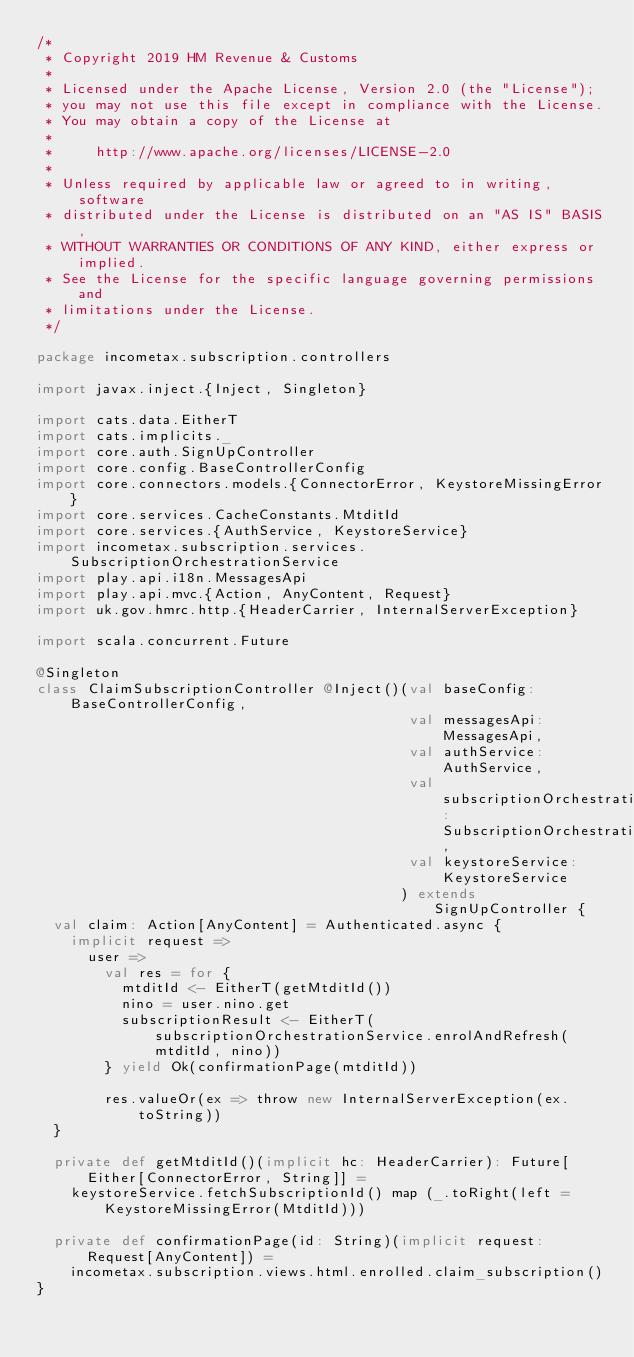<code> <loc_0><loc_0><loc_500><loc_500><_Scala_>/*
 * Copyright 2019 HM Revenue & Customs
 *
 * Licensed under the Apache License, Version 2.0 (the "License");
 * you may not use this file except in compliance with the License.
 * You may obtain a copy of the License at
 *
 *     http://www.apache.org/licenses/LICENSE-2.0
 *
 * Unless required by applicable law or agreed to in writing, software
 * distributed under the License is distributed on an "AS IS" BASIS,
 * WITHOUT WARRANTIES OR CONDITIONS OF ANY KIND, either express or implied.
 * See the License for the specific language governing permissions and
 * limitations under the License.
 */

package incometax.subscription.controllers

import javax.inject.{Inject, Singleton}

import cats.data.EitherT
import cats.implicits._
import core.auth.SignUpController
import core.config.BaseControllerConfig
import core.connectors.models.{ConnectorError, KeystoreMissingError}
import core.services.CacheConstants.MtditId
import core.services.{AuthService, KeystoreService}
import incometax.subscription.services.SubscriptionOrchestrationService
import play.api.i18n.MessagesApi
import play.api.mvc.{Action, AnyContent, Request}
import uk.gov.hmrc.http.{HeaderCarrier, InternalServerException}

import scala.concurrent.Future

@Singleton
class ClaimSubscriptionController @Inject()(val baseConfig: BaseControllerConfig,
                                            val messagesApi: MessagesApi,
                                            val authService: AuthService,
                                            val subscriptionOrchestrationService: SubscriptionOrchestrationService,
                                            val keystoreService: KeystoreService
                                           ) extends SignUpController {
  val claim: Action[AnyContent] = Authenticated.async {
    implicit request =>
      user =>
        val res = for {
          mtditId <- EitherT(getMtditId())
          nino = user.nino.get
          subscriptionResult <- EitherT(subscriptionOrchestrationService.enrolAndRefresh(mtditId, nino))
        } yield Ok(confirmationPage(mtditId))

        res.valueOr(ex => throw new InternalServerException(ex.toString))
  }

  private def getMtditId()(implicit hc: HeaderCarrier): Future[Either[ConnectorError, String]] =
    keystoreService.fetchSubscriptionId() map (_.toRight(left = KeystoreMissingError(MtditId)))

  private def confirmationPage(id: String)(implicit request: Request[AnyContent]) =
    incometax.subscription.views.html.enrolled.claim_subscription()
}
</code> 